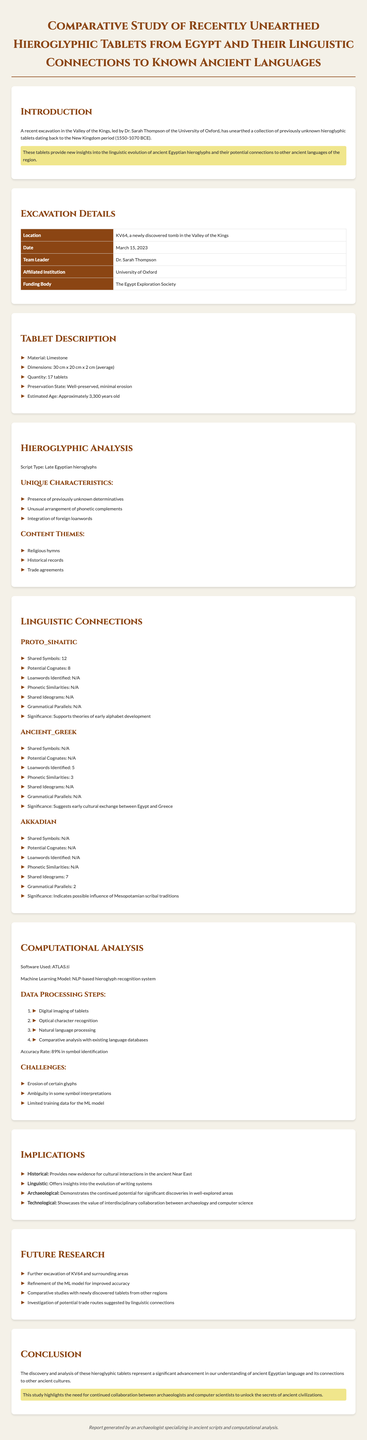What is the excavation location? The excavation site is specifically named in the document under excavation details.
Answer: KV64 Who is the team leader of the excavation? The document states the name of the team leader in the excavation details section.
Answer: Dr. Sarah Thompson How many tablets were unearthed? The total quantity of tablets is specified in the document's tablet description section.
Answer: 17 tablets What is the significance of the linguistic connections to proto-Sinaitic? The document outlines the importance of these connections in linguistic terms specifically.
Answer: Supports theories of early alphabet development What software was used for computational analysis? The software used for the analysis is mentioned in the computational analysis section of the document.
Answer: ATLAS.ti What themes are present in the content of the tablets? The document lists the themes in the hieroglyphic analysis section, which encompasses various aspects.
Answer: Religious hymns, Historical records, Trade agreements What is the preservation state of the tablets? The preservation state is discussed in the tablet description part of the document.
Answer: Well-preserved, minimal erosion What are the future research focuses mentioned? The document provides a list of future research areas to explore, highlighting potential directions.
Answer: Further excavation of KV64 and surrounding areas What is the accuracy rate of the symbol identification? The accuracy of the machine learning model for symbol identification is provided in the computational analysis section.
Answer: 89% in symbol identification 